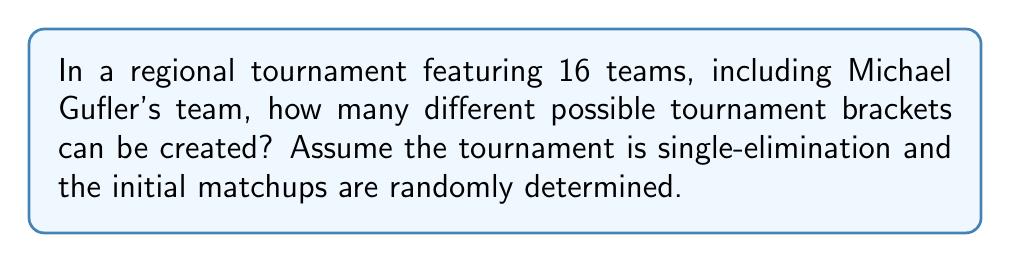Give your solution to this math problem. To solve this problem, we need to consider the number of ways to arrange 16 teams in a single-elimination tournament bracket. Let's break it down step-by-step:

1. In the first round, we need to pair up 16 teams into 8 matches. This can be done in:

   $$\frac{16!}{(2!)^8 \cdot 8!}$$ ways

   This is because we're selecting 2 teams at a time (order doesn't matter within each pair) for 8 pairs.

2. For the second round (quarterfinals), we'll have 8 teams. The number of ways to arrange these is:

   $$\frac{8!}{(2!)^4 \cdot 4!}$$ ways

3. For the third round (semifinals), we'll have 4 teams. The number of ways to arrange these is:

   $$\frac{4!}{(2!)^2 \cdot 2!}$$ ways

4. For the final round, we'll have 2 teams, which can be arranged in only 1 way.

5. To get the total number of possible brackets, we multiply these numbers together:

   $$\text{Total brackets} = \frac{16!}{(2!)^8 \cdot 8!} \cdot \frac{8!}{(2!)^4 \cdot 4!} \cdot \frac{4!}{(2!)^2 \cdot 2!} \cdot 1$$

6. Simplifying:

   $$\text{Total brackets} = \frac{16!}{2^{14}}$$

7. Calculating this value:

   $$\text{Total brackets} = 2,027,025$$

This means there are 2,027,025 different possible ways to arrange the tournament bracket, each of which would present a unique path for Michael Gufler's team to potentially reach the championship.
Answer: $$2,027,025$$ possible tournament brackets 